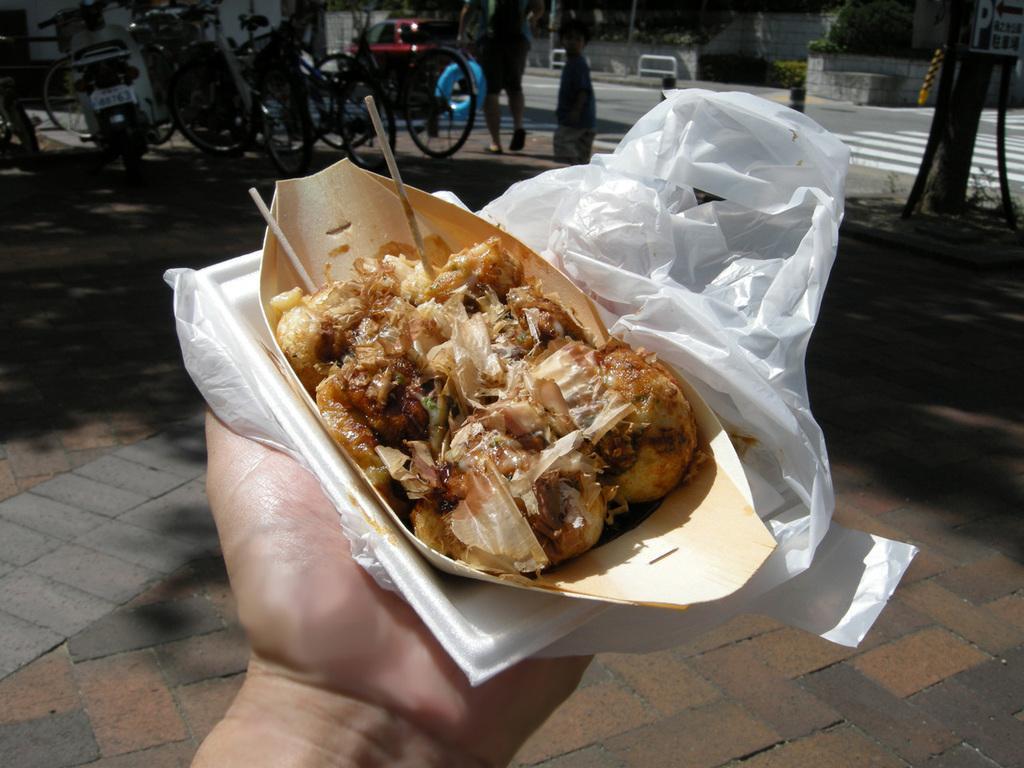In one or two sentences, can you explain what this image depicts? In this image we can see a hand of a person. In the person hand, we can see a plastic cover and the food. At the top we can see the vehicles, persons, road, barriers, tree, plants and buildings. 